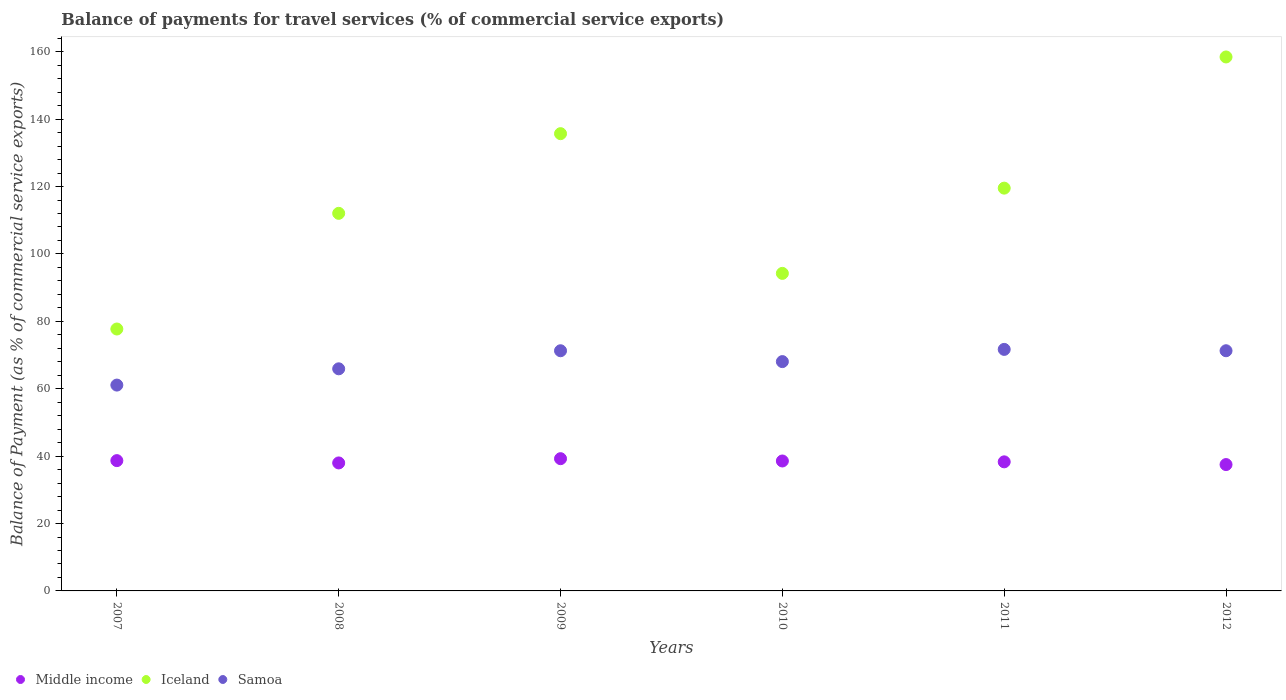How many different coloured dotlines are there?
Give a very brief answer. 3. Is the number of dotlines equal to the number of legend labels?
Your answer should be compact. Yes. What is the balance of payments for travel services in Iceland in 2010?
Your answer should be compact. 94.23. Across all years, what is the maximum balance of payments for travel services in Middle income?
Offer a very short reply. 39.24. Across all years, what is the minimum balance of payments for travel services in Samoa?
Offer a terse response. 61.08. In which year was the balance of payments for travel services in Middle income maximum?
Your response must be concise. 2009. What is the total balance of payments for travel services in Samoa in the graph?
Your answer should be very brief. 409.24. What is the difference between the balance of payments for travel services in Samoa in 2008 and that in 2010?
Your answer should be compact. -2.14. What is the difference between the balance of payments for travel services in Iceland in 2012 and the balance of payments for travel services in Middle income in 2007?
Ensure brevity in your answer.  119.78. What is the average balance of payments for travel services in Middle income per year?
Keep it short and to the point. 38.37. In the year 2011, what is the difference between the balance of payments for travel services in Samoa and balance of payments for travel services in Iceland?
Offer a terse response. -47.85. What is the ratio of the balance of payments for travel services in Iceland in 2007 to that in 2012?
Keep it short and to the point. 0.49. Is the balance of payments for travel services in Samoa in 2009 less than that in 2011?
Keep it short and to the point. Yes. Is the difference between the balance of payments for travel services in Samoa in 2011 and 2012 greater than the difference between the balance of payments for travel services in Iceland in 2011 and 2012?
Make the answer very short. Yes. What is the difference between the highest and the second highest balance of payments for travel services in Samoa?
Give a very brief answer. 0.4. What is the difference between the highest and the lowest balance of payments for travel services in Middle income?
Your answer should be compact. 1.75. In how many years, is the balance of payments for travel services in Samoa greater than the average balance of payments for travel services in Samoa taken over all years?
Offer a very short reply. 3. Is the sum of the balance of payments for travel services in Iceland in 2008 and 2010 greater than the maximum balance of payments for travel services in Samoa across all years?
Offer a very short reply. Yes. Is it the case that in every year, the sum of the balance of payments for travel services in Samoa and balance of payments for travel services in Iceland  is greater than the balance of payments for travel services in Middle income?
Offer a terse response. Yes. Does the balance of payments for travel services in Iceland monotonically increase over the years?
Your answer should be compact. No. What is the difference between two consecutive major ticks on the Y-axis?
Offer a very short reply. 20. Does the graph contain any zero values?
Provide a short and direct response. No. Does the graph contain grids?
Your response must be concise. No. How many legend labels are there?
Give a very brief answer. 3. How are the legend labels stacked?
Offer a terse response. Horizontal. What is the title of the graph?
Give a very brief answer. Balance of payments for travel services (% of commercial service exports). Does "Japan" appear as one of the legend labels in the graph?
Ensure brevity in your answer.  No. What is the label or title of the X-axis?
Make the answer very short. Years. What is the label or title of the Y-axis?
Offer a terse response. Balance of Payment (as % of commercial service exports). What is the Balance of Payment (as % of commercial service exports) of Middle income in 2007?
Ensure brevity in your answer.  38.66. What is the Balance of Payment (as % of commercial service exports) in Iceland in 2007?
Your response must be concise. 77.72. What is the Balance of Payment (as % of commercial service exports) of Samoa in 2007?
Keep it short and to the point. 61.08. What is the Balance of Payment (as % of commercial service exports) of Middle income in 2008?
Provide a short and direct response. 37.98. What is the Balance of Payment (as % of commercial service exports) of Iceland in 2008?
Provide a short and direct response. 112.04. What is the Balance of Payment (as % of commercial service exports) in Samoa in 2008?
Keep it short and to the point. 65.91. What is the Balance of Payment (as % of commercial service exports) in Middle income in 2009?
Provide a short and direct response. 39.24. What is the Balance of Payment (as % of commercial service exports) in Iceland in 2009?
Offer a very short reply. 135.69. What is the Balance of Payment (as % of commercial service exports) of Samoa in 2009?
Give a very brief answer. 71.27. What is the Balance of Payment (as % of commercial service exports) of Middle income in 2010?
Ensure brevity in your answer.  38.56. What is the Balance of Payment (as % of commercial service exports) in Iceland in 2010?
Provide a succinct answer. 94.23. What is the Balance of Payment (as % of commercial service exports) of Samoa in 2010?
Offer a very short reply. 68.05. What is the Balance of Payment (as % of commercial service exports) in Middle income in 2011?
Provide a short and direct response. 38.3. What is the Balance of Payment (as % of commercial service exports) of Iceland in 2011?
Your answer should be very brief. 119.52. What is the Balance of Payment (as % of commercial service exports) in Samoa in 2011?
Keep it short and to the point. 71.67. What is the Balance of Payment (as % of commercial service exports) of Middle income in 2012?
Give a very brief answer. 37.49. What is the Balance of Payment (as % of commercial service exports) of Iceland in 2012?
Your answer should be very brief. 158.45. What is the Balance of Payment (as % of commercial service exports) of Samoa in 2012?
Provide a short and direct response. 71.27. Across all years, what is the maximum Balance of Payment (as % of commercial service exports) of Middle income?
Provide a short and direct response. 39.24. Across all years, what is the maximum Balance of Payment (as % of commercial service exports) of Iceland?
Keep it short and to the point. 158.45. Across all years, what is the maximum Balance of Payment (as % of commercial service exports) in Samoa?
Your answer should be very brief. 71.67. Across all years, what is the minimum Balance of Payment (as % of commercial service exports) of Middle income?
Your answer should be very brief. 37.49. Across all years, what is the minimum Balance of Payment (as % of commercial service exports) in Iceland?
Keep it short and to the point. 77.72. Across all years, what is the minimum Balance of Payment (as % of commercial service exports) of Samoa?
Offer a very short reply. 61.08. What is the total Balance of Payment (as % of commercial service exports) of Middle income in the graph?
Provide a short and direct response. 230.24. What is the total Balance of Payment (as % of commercial service exports) in Iceland in the graph?
Provide a short and direct response. 697.65. What is the total Balance of Payment (as % of commercial service exports) of Samoa in the graph?
Your response must be concise. 409.24. What is the difference between the Balance of Payment (as % of commercial service exports) of Middle income in 2007 and that in 2008?
Ensure brevity in your answer.  0.69. What is the difference between the Balance of Payment (as % of commercial service exports) in Iceland in 2007 and that in 2008?
Your answer should be very brief. -34.32. What is the difference between the Balance of Payment (as % of commercial service exports) in Samoa in 2007 and that in 2008?
Ensure brevity in your answer.  -4.83. What is the difference between the Balance of Payment (as % of commercial service exports) in Middle income in 2007 and that in 2009?
Give a very brief answer. -0.58. What is the difference between the Balance of Payment (as % of commercial service exports) in Iceland in 2007 and that in 2009?
Provide a succinct answer. -57.97. What is the difference between the Balance of Payment (as % of commercial service exports) of Samoa in 2007 and that in 2009?
Offer a terse response. -10.19. What is the difference between the Balance of Payment (as % of commercial service exports) in Middle income in 2007 and that in 2010?
Provide a short and direct response. 0.11. What is the difference between the Balance of Payment (as % of commercial service exports) in Iceland in 2007 and that in 2010?
Your answer should be compact. -16.51. What is the difference between the Balance of Payment (as % of commercial service exports) of Samoa in 2007 and that in 2010?
Your response must be concise. -6.97. What is the difference between the Balance of Payment (as % of commercial service exports) of Middle income in 2007 and that in 2011?
Offer a terse response. 0.36. What is the difference between the Balance of Payment (as % of commercial service exports) of Iceland in 2007 and that in 2011?
Keep it short and to the point. -41.8. What is the difference between the Balance of Payment (as % of commercial service exports) in Samoa in 2007 and that in 2011?
Your answer should be compact. -10.59. What is the difference between the Balance of Payment (as % of commercial service exports) of Middle income in 2007 and that in 2012?
Offer a terse response. 1.17. What is the difference between the Balance of Payment (as % of commercial service exports) in Iceland in 2007 and that in 2012?
Your response must be concise. -80.73. What is the difference between the Balance of Payment (as % of commercial service exports) of Samoa in 2007 and that in 2012?
Make the answer very short. -10.19. What is the difference between the Balance of Payment (as % of commercial service exports) of Middle income in 2008 and that in 2009?
Keep it short and to the point. -1.26. What is the difference between the Balance of Payment (as % of commercial service exports) of Iceland in 2008 and that in 2009?
Keep it short and to the point. -23.64. What is the difference between the Balance of Payment (as % of commercial service exports) of Samoa in 2008 and that in 2009?
Give a very brief answer. -5.36. What is the difference between the Balance of Payment (as % of commercial service exports) in Middle income in 2008 and that in 2010?
Your response must be concise. -0.58. What is the difference between the Balance of Payment (as % of commercial service exports) of Iceland in 2008 and that in 2010?
Your answer should be very brief. 17.82. What is the difference between the Balance of Payment (as % of commercial service exports) of Samoa in 2008 and that in 2010?
Make the answer very short. -2.14. What is the difference between the Balance of Payment (as % of commercial service exports) of Middle income in 2008 and that in 2011?
Provide a succinct answer. -0.32. What is the difference between the Balance of Payment (as % of commercial service exports) of Iceland in 2008 and that in 2011?
Provide a short and direct response. -7.48. What is the difference between the Balance of Payment (as % of commercial service exports) of Samoa in 2008 and that in 2011?
Give a very brief answer. -5.76. What is the difference between the Balance of Payment (as % of commercial service exports) of Middle income in 2008 and that in 2012?
Your answer should be compact. 0.48. What is the difference between the Balance of Payment (as % of commercial service exports) of Iceland in 2008 and that in 2012?
Provide a short and direct response. -46.4. What is the difference between the Balance of Payment (as % of commercial service exports) of Samoa in 2008 and that in 2012?
Give a very brief answer. -5.36. What is the difference between the Balance of Payment (as % of commercial service exports) of Middle income in 2009 and that in 2010?
Ensure brevity in your answer.  0.68. What is the difference between the Balance of Payment (as % of commercial service exports) of Iceland in 2009 and that in 2010?
Offer a very short reply. 41.46. What is the difference between the Balance of Payment (as % of commercial service exports) in Samoa in 2009 and that in 2010?
Keep it short and to the point. 3.22. What is the difference between the Balance of Payment (as % of commercial service exports) of Middle income in 2009 and that in 2011?
Offer a very short reply. 0.94. What is the difference between the Balance of Payment (as % of commercial service exports) of Iceland in 2009 and that in 2011?
Offer a very short reply. 16.17. What is the difference between the Balance of Payment (as % of commercial service exports) in Samoa in 2009 and that in 2011?
Your answer should be very brief. -0.4. What is the difference between the Balance of Payment (as % of commercial service exports) in Middle income in 2009 and that in 2012?
Your answer should be compact. 1.75. What is the difference between the Balance of Payment (as % of commercial service exports) in Iceland in 2009 and that in 2012?
Ensure brevity in your answer.  -22.76. What is the difference between the Balance of Payment (as % of commercial service exports) of Samoa in 2009 and that in 2012?
Ensure brevity in your answer.  -0. What is the difference between the Balance of Payment (as % of commercial service exports) in Middle income in 2010 and that in 2011?
Your response must be concise. 0.25. What is the difference between the Balance of Payment (as % of commercial service exports) of Iceland in 2010 and that in 2011?
Offer a very short reply. -25.3. What is the difference between the Balance of Payment (as % of commercial service exports) of Samoa in 2010 and that in 2011?
Ensure brevity in your answer.  -3.62. What is the difference between the Balance of Payment (as % of commercial service exports) of Middle income in 2010 and that in 2012?
Offer a very short reply. 1.06. What is the difference between the Balance of Payment (as % of commercial service exports) of Iceland in 2010 and that in 2012?
Keep it short and to the point. -64.22. What is the difference between the Balance of Payment (as % of commercial service exports) in Samoa in 2010 and that in 2012?
Ensure brevity in your answer.  -3.22. What is the difference between the Balance of Payment (as % of commercial service exports) in Middle income in 2011 and that in 2012?
Keep it short and to the point. 0.81. What is the difference between the Balance of Payment (as % of commercial service exports) in Iceland in 2011 and that in 2012?
Make the answer very short. -38.93. What is the difference between the Balance of Payment (as % of commercial service exports) of Samoa in 2011 and that in 2012?
Provide a short and direct response. 0.4. What is the difference between the Balance of Payment (as % of commercial service exports) of Middle income in 2007 and the Balance of Payment (as % of commercial service exports) of Iceland in 2008?
Offer a terse response. -73.38. What is the difference between the Balance of Payment (as % of commercial service exports) in Middle income in 2007 and the Balance of Payment (as % of commercial service exports) in Samoa in 2008?
Offer a very short reply. -27.24. What is the difference between the Balance of Payment (as % of commercial service exports) of Iceland in 2007 and the Balance of Payment (as % of commercial service exports) of Samoa in 2008?
Provide a succinct answer. 11.81. What is the difference between the Balance of Payment (as % of commercial service exports) in Middle income in 2007 and the Balance of Payment (as % of commercial service exports) in Iceland in 2009?
Provide a succinct answer. -97.02. What is the difference between the Balance of Payment (as % of commercial service exports) of Middle income in 2007 and the Balance of Payment (as % of commercial service exports) of Samoa in 2009?
Give a very brief answer. -32.6. What is the difference between the Balance of Payment (as % of commercial service exports) of Iceland in 2007 and the Balance of Payment (as % of commercial service exports) of Samoa in 2009?
Make the answer very short. 6.45. What is the difference between the Balance of Payment (as % of commercial service exports) of Middle income in 2007 and the Balance of Payment (as % of commercial service exports) of Iceland in 2010?
Your response must be concise. -55.56. What is the difference between the Balance of Payment (as % of commercial service exports) of Middle income in 2007 and the Balance of Payment (as % of commercial service exports) of Samoa in 2010?
Give a very brief answer. -29.38. What is the difference between the Balance of Payment (as % of commercial service exports) of Iceland in 2007 and the Balance of Payment (as % of commercial service exports) of Samoa in 2010?
Make the answer very short. 9.67. What is the difference between the Balance of Payment (as % of commercial service exports) of Middle income in 2007 and the Balance of Payment (as % of commercial service exports) of Iceland in 2011?
Provide a succinct answer. -80.86. What is the difference between the Balance of Payment (as % of commercial service exports) in Middle income in 2007 and the Balance of Payment (as % of commercial service exports) in Samoa in 2011?
Your answer should be compact. -33.01. What is the difference between the Balance of Payment (as % of commercial service exports) of Iceland in 2007 and the Balance of Payment (as % of commercial service exports) of Samoa in 2011?
Offer a very short reply. 6.05. What is the difference between the Balance of Payment (as % of commercial service exports) in Middle income in 2007 and the Balance of Payment (as % of commercial service exports) in Iceland in 2012?
Keep it short and to the point. -119.78. What is the difference between the Balance of Payment (as % of commercial service exports) of Middle income in 2007 and the Balance of Payment (as % of commercial service exports) of Samoa in 2012?
Your answer should be compact. -32.61. What is the difference between the Balance of Payment (as % of commercial service exports) in Iceland in 2007 and the Balance of Payment (as % of commercial service exports) in Samoa in 2012?
Provide a short and direct response. 6.45. What is the difference between the Balance of Payment (as % of commercial service exports) in Middle income in 2008 and the Balance of Payment (as % of commercial service exports) in Iceland in 2009?
Make the answer very short. -97.71. What is the difference between the Balance of Payment (as % of commercial service exports) of Middle income in 2008 and the Balance of Payment (as % of commercial service exports) of Samoa in 2009?
Keep it short and to the point. -33.29. What is the difference between the Balance of Payment (as % of commercial service exports) of Iceland in 2008 and the Balance of Payment (as % of commercial service exports) of Samoa in 2009?
Your response must be concise. 40.78. What is the difference between the Balance of Payment (as % of commercial service exports) of Middle income in 2008 and the Balance of Payment (as % of commercial service exports) of Iceland in 2010?
Your response must be concise. -56.25. What is the difference between the Balance of Payment (as % of commercial service exports) in Middle income in 2008 and the Balance of Payment (as % of commercial service exports) in Samoa in 2010?
Make the answer very short. -30.07. What is the difference between the Balance of Payment (as % of commercial service exports) in Iceland in 2008 and the Balance of Payment (as % of commercial service exports) in Samoa in 2010?
Your response must be concise. 44. What is the difference between the Balance of Payment (as % of commercial service exports) in Middle income in 2008 and the Balance of Payment (as % of commercial service exports) in Iceland in 2011?
Offer a terse response. -81.54. What is the difference between the Balance of Payment (as % of commercial service exports) in Middle income in 2008 and the Balance of Payment (as % of commercial service exports) in Samoa in 2011?
Provide a succinct answer. -33.69. What is the difference between the Balance of Payment (as % of commercial service exports) in Iceland in 2008 and the Balance of Payment (as % of commercial service exports) in Samoa in 2011?
Make the answer very short. 40.37. What is the difference between the Balance of Payment (as % of commercial service exports) of Middle income in 2008 and the Balance of Payment (as % of commercial service exports) of Iceland in 2012?
Your answer should be very brief. -120.47. What is the difference between the Balance of Payment (as % of commercial service exports) of Middle income in 2008 and the Balance of Payment (as % of commercial service exports) of Samoa in 2012?
Offer a terse response. -33.29. What is the difference between the Balance of Payment (as % of commercial service exports) of Iceland in 2008 and the Balance of Payment (as % of commercial service exports) of Samoa in 2012?
Give a very brief answer. 40.77. What is the difference between the Balance of Payment (as % of commercial service exports) of Middle income in 2009 and the Balance of Payment (as % of commercial service exports) of Iceland in 2010?
Give a very brief answer. -54.99. What is the difference between the Balance of Payment (as % of commercial service exports) of Middle income in 2009 and the Balance of Payment (as % of commercial service exports) of Samoa in 2010?
Your answer should be compact. -28.81. What is the difference between the Balance of Payment (as % of commercial service exports) of Iceland in 2009 and the Balance of Payment (as % of commercial service exports) of Samoa in 2010?
Your answer should be compact. 67.64. What is the difference between the Balance of Payment (as % of commercial service exports) of Middle income in 2009 and the Balance of Payment (as % of commercial service exports) of Iceland in 2011?
Your response must be concise. -80.28. What is the difference between the Balance of Payment (as % of commercial service exports) of Middle income in 2009 and the Balance of Payment (as % of commercial service exports) of Samoa in 2011?
Your answer should be very brief. -32.43. What is the difference between the Balance of Payment (as % of commercial service exports) of Iceland in 2009 and the Balance of Payment (as % of commercial service exports) of Samoa in 2011?
Your answer should be compact. 64.02. What is the difference between the Balance of Payment (as % of commercial service exports) of Middle income in 2009 and the Balance of Payment (as % of commercial service exports) of Iceland in 2012?
Provide a short and direct response. -119.21. What is the difference between the Balance of Payment (as % of commercial service exports) of Middle income in 2009 and the Balance of Payment (as % of commercial service exports) of Samoa in 2012?
Offer a very short reply. -32.03. What is the difference between the Balance of Payment (as % of commercial service exports) of Iceland in 2009 and the Balance of Payment (as % of commercial service exports) of Samoa in 2012?
Provide a succinct answer. 64.42. What is the difference between the Balance of Payment (as % of commercial service exports) in Middle income in 2010 and the Balance of Payment (as % of commercial service exports) in Iceland in 2011?
Offer a very short reply. -80.96. What is the difference between the Balance of Payment (as % of commercial service exports) in Middle income in 2010 and the Balance of Payment (as % of commercial service exports) in Samoa in 2011?
Your response must be concise. -33.11. What is the difference between the Balance of Payment (as % of commercial service exports) of Iceland in 2010 and the Balance of Payment (as % of commercial service exports) of Samoa in 2011?
Give a very brief answer. 22.56. What is the difference between the Balance of Payment (as % of commercial service exports) of Middle income in 2010 and the Balance of Payment (as % of commercial service exports) of Iceland in 2012?
Provide a short and direct response. -119.89. What is the difference between the Balance of Payment (as % of commercial service exports) in Middle income in 2010 and the Balance of Payment (as % of commercial service exports) in Samoa in 2012?
Give a very brief answer. -32.71. What is the difference between the Balance of Payment (as % of commercial service exports) of Iceland in 2010 and the Balance of Payment (as % of commercial service exports) of Samoa in 2012?
Ensure brevity in your answer.  22.96. What is the difference between the Balance of Payment (as % of commercial service exports) of Middle income in 2011 and the Balance of Payment (as % of commercial service exports) of Iceland in 2012?
Your answer should be very brief. -120.15. What is the difference between the Balance of Payment (as % of commercial service exports) in Middle income in 2011 and the Balance of Payment (as % of commercial service exports) in Samoa in 2012?
Ensure brevity in your answer.  -32.97. What is the difference between the Balance of Payment (as % of commercial service exports) in Iceland in 2011 and the Balance of Payment (as % of commercial service exports) in Samoa in 2012?
Your response must be concise. 48.25. What is the average Balance of Payment (as % of commercial service exports) in Middle income per year?
Ensure brevity in your answer.  38.37. What is the average Balance of Payment (as % of commercial service exports) in Iceland per year?
Give a very brief answer. 116.27. What is the average Balance of Payment (as % of commercial service exports) of Samoa per year?
Offer a terse response. 68.21. In the year 2007, what is the difference between the Balance of Payment (as % of commercial service exports) of Middle income and Balance of Payment (as % of commercial service exports) of Iceland?
Offer a terse response. -39.05. In the year 2007, what is the difference between the Balance of Payment (as % of commercial service exports) in Middle income and Balance of Payment (as % of commercial service exports) in Samoa?
Make the answer very short. -22.42. In the year 2007, what is the difference between the Balance of Payment (as % of commercial service exports) in Iceland and Balance of Payment (as % of commercial service exports) in Samoa?
Make the answer very short. 16.64. In the year 2008, what is the difference between the Balance of Payment (as % of commercial service exports) of Middle income and Balance of Payment (as % of commercial service exports) of Iceland?
Ensure brevity in your answer.  -74.06. In the year 2008, what is the difference between the Balance of Payment (as % of commercial service exports) of Middle income and Balance of Payment (as % of commercial service exports) of Samoa?
Keep it short and to the point. -27.93. In the year 2008, what is the difference between the Balance of Payment (as % of commercial service exports) of Iceland and Balance of Payment (as % of commercial service exports) of Samoa?
Your answer should be very brief. 46.14. In the year 2009, what is the difference between the Balance of Payment (as % of commercial service exports) of Middle income and Balance of Payment (as % of commercial service exports) of Iceland?
Offer a very short reply. -96.45. In the year 2009, what is the difference between the Balance of Payment (as % of commercial service exports) of Middle income and Balance of Payment (as % of commercial service exports) of Samoa?
Give a very brief answer. -32.03. In the year 2009, what is the difference between the Balance of Payment (as % of commercial service exports) in Iceland and Balance of Payment (as % of commercial service exports) in Samoa?
Your answer should be compact. 64.42. In the year 2010, what is the difference between the Balance of Payment (as % of commercial service exports) in Middle income and Balance of Payment (as % of commercial service exports) in Iceland?
Your answer should be very brief. -55.67. In the year 2010, what is the difference between the Balance of Payment (as % of commercial service exports) of Middle income and Balance of Payment (as % of commercial service exports) of Samoa?
Provide a short and direct response. -29.49. In the year 2010, what is the difference between the Balance of Payment (as % of commercial service exports) of Iceland and Balance of Payment (as % of commercial service exports) of Samoa?
Ensure brevity in your answer.  26.18. In the year 2011, what is the difference between the Balance of Payment (as % of commercial service exports) of Middle income and Balance of Payment (as % of commercial service exports) of Iceland?
Give a very brief answer. -81.22. In the year 2011, what is the difference between the Balance of Payment (as % of commercial service exports) in Middle income and Balance of Payment (as % of commercial service exports) in Samoa?
Make the answer very short. -33.37. In the year 2011, what is the difference between the Balance of Payment (as % of commercial service exports) in Iceland and Balance of Payment (as % of commercial service exports) in Samoa?
Offer a terse response. 47.85. In the year 2012, what is the difference between the Balance of Payment (as % of commercial service exports) of Middle income and Balance of Payment (as % of commercial service exports) of Iceland?
Your response must be concise. -120.95. In the year 2012, what is the difference between the Balance of Payment (as % of commercial service exports) in Middle income and Balance of Payment (as % of commercial service exports) in Samoa?
Provide a succinct answer. -33.78. In the year 2012, what is the difference between the Balance of Payment (as % of commercial service exports) in Iceland and Balance of Payment (as % of commercial service exports) in Samoa?
Offer a terse response. 87.18. What is the ratio of the Balance of Payment (as % of commercial service exports) in Middle income in 2007 to that in 2008?
Your answer should be compact. 1.02. What is the ratio of the Balance of Payment (as % of commercial service exports) in Iceland in 2007 to that in 2008?
Your answer should be very brief. 0.69. What is the ratio of the Balance of Payment (as % of commercial service exports) in Samoa in 2007 to that in 2008?
Your answer should be compact. 0.93. What is the ratio of the Balance of Payment (as % of commercial service exports) of Iceland in 2007 to that in 2009?
Your response must be concise. 0.57. What is the ratio of the Balance of Payment (as % of commercial service exports) of Samoa in 2007 to that in 2009?
Ensure brevity in your answer.  0.86. What is the ratio of the Balance of Payment (as % of commercial service exports) in Middle income in 2007 to that in 2010?
Ensure brevity in your answer.  1. What is the ratio of the Balance of Payment (as % of commercial service exports) in Iceland in 2007 to that in 2010?
Provide a succinct answer. 0.82. What is the ratio of the Balance of Payment (as % of commercial service exports) in Samoa in 2007 to that in 2010?
Your answer should be compact. 0.9. What is the ratio of the Balance of Payment (as % of commercial service exports) in Middle income in 2007 to that in 2011?
Provide a short and direct response. 1.01. What is the ratio of the Balance of Payment (as % of commercial service exports) in Iceland in 2007 to that in 2011?
Your answer should be compact. 0.65. What is the ratio of the Balance of Payment (as % of commercial service exports) in Samoa in 2007 to that in 2011?
Offer a very short reply. 0.85. What is the ratio of the Balance of Payment (as % of commercial service exports) in Middle income in 2007 to that in 2012?
Offer a terse response. 1.03. What is the ratio of the Balance of Payment (as % of commercial service exports) in Iceland in 2007 to that in 2012?
Your response must be concise. 0.49. What is the ratio of the Balance of Payment (as % of commercial service exports) in Samoa in 2007 to that in 2012?
Give a very brief answer. 0.86. What is the ratio of the Balance of Payment (as % of commercial service exports) of Middle income in 2008 to that in 2009?
Provide a succinct answer. 0.97. What is the ratio of the Balance of Payment (as % of commercial service exports) of Iceland in 2008 to that in 2009?
Offer a terse response. 0.83. What is the ratio of the Balance of Payment (as % of commercial service exports) of Samoa in 2008 to that in 2009?
Provide a succinct answer. 0.92. What is the ratio of the Balance of Payment (as % of commercial service exports) in Middle income in 2008 to that in 2010?
Offer a very short reply. 0.98. What is the ratio of the Balance of Payment (as % of commercial service exports) in Iceland in 2008 to that in 2010?
Provide a short and direct response. 1.19. What is the ratio of the Balance of Payment (as % of commercial service exports) of Samoa in 2008 to that in 2010?
Your answer should be very brief. 0.97. What is the ratio of the Balance of Payment (as % of commercial service exports) in Middle income in 2008 to that in 2011?
Provide a succinct answer. 0.99. What is the ratio of the Balance of Payment (as % of commercial service exports) in Iceland in 2008 to that in 2011?
Ensure brevity in your answer.  0.94. What is the ratio of the Balance of Payment (as % of commercial service exports) in Samoa in 2008 to that in 2011?
Your answer should be very brief. 0.92. What is the ratio of the Balance of Payment (as % of commercial service exports) in Middle income in 2008 to that in 2012?
Keep it short and to the point. 1.01. What is the ratio of the Balance of Payment (as % of commercial service exports) of Iceland in 2008 to that in 2012?
Provide a succinct answer. 0.71. What is the ratio of the Balance of Payment (as % of commercial service exports) in Samoa in 2008 to that in 2012?
Offer a terse response. 0.92. What is the ratio of the Balance of Payment (as % of commercial service exports) of Middle income in 2009 to that in 2010?
Ensure brevity in your answer.  1.02. What is the ratio of the Balance of Payment (as % of commercial service exports) of Iceland in 2009 to that in 2010?
Your answer should be very brief. 1.44. What is the ratio of the Balance of Payment (as % of commercial service exports) in Samoa in 2009 to that in 2010?
Offer a terse response. 1.05. What is the ratio of the Balance of Payment (as % of commercial service exports) of Middle income in 2009 to that in 2011?
Your answer should be compact. 1.02. What is the ratio of the Balance of Payment (as % of commercial service exports) in Iceland in 2009 to that in 2011?
Provide a short and direct response. 1.14. What is the ratio of the Balance of Payment (as % of commercial service exports) of Samoa in 2009 to that in 2011?
Ensure brevity in your answer.  0.99. What is the ratio of the Balance of Payment (as % of commercial service exports) of Middle income in 2009 to that in 2012?
Offer a terse response. 1.05. What is the ratio of the Balance of Payment (as % of commercial service exports) of Iceland in 2009 to that in 2012?
Keep it short and to the point. 0.86. What is the ratio of the Balance of Payment (as % of commercial service exports) in Middle income in 2010 to that in 2011?
Offer a terse response. 1.01. What is the ratio of the Balance of Payment (as % of commercial service exports) in Iceland in 2010 to that in 2011?
Give a very brief answer. 0.79. What is the ratio of the Balance of Payment (as % of commercial service exports) in Samoa in 2010 to that in 2011?
Your answer should be compact. 0.95. What is the ratio of the Balance of Payment (as % of commercial service exports) of Middle income in 2010 to that in 2012?
Keep it short and to the point. 1.03. What is the ratio of the Balance of Payment (as % of commercial service exports) of Iceland in 2010 to that in 2012?
Ensure brevity in your answer.  0.59. What is the ratio of the Balance of Payment (as % of commercial service exports) of Samoa in 2010 to that in 2012?
Your answer should be very brief. 0.95. What is the ratio of the Balance of Payment (as % of commercial service exports) in Middle income in 2011 to that in 2012?
Your response must be concise. 1.02. What is the ratio of the Balance of Payment (as % of commercial service exports) of Iceland in 2011 to that in 2012?
Ensure brevity in your answer.  0.75. What is the ratio of the Balance of Payment (as % of commercial service exports) of Samoa in 2011 to that in 2012?
Ensure brevity in your answer.  1.01. What is the difference between the highest and the second highest Balance of Payment (as % of commercial service exports) in Middle income?
Provide a short and direct response. 0.58. What is the difference between the highest and the second highest Balance of Payment (as % of commercial service exports) in Iceland?
Keep it short and to the point. 22.76. What is the difference between the highest and the second highest Balance of Payment (as % of commercial service exports) of Samoa?
Provide a succinct answer. 0.4. What is the difference between the highest and the lowest Balance of Payment (as % of commercial service exports) of Middle income?
Provide a succinct answer. 1.75. What is the difference between the highest and the lowest Balance of Payment (as % of commercial service exports) of Iceland?
Your response must be concise. 80.73. What is the difference between the highest and the lowest Balance of Payment (as % of commercial service exports) of Samoa?
Your answer should be compact. 10.59. 